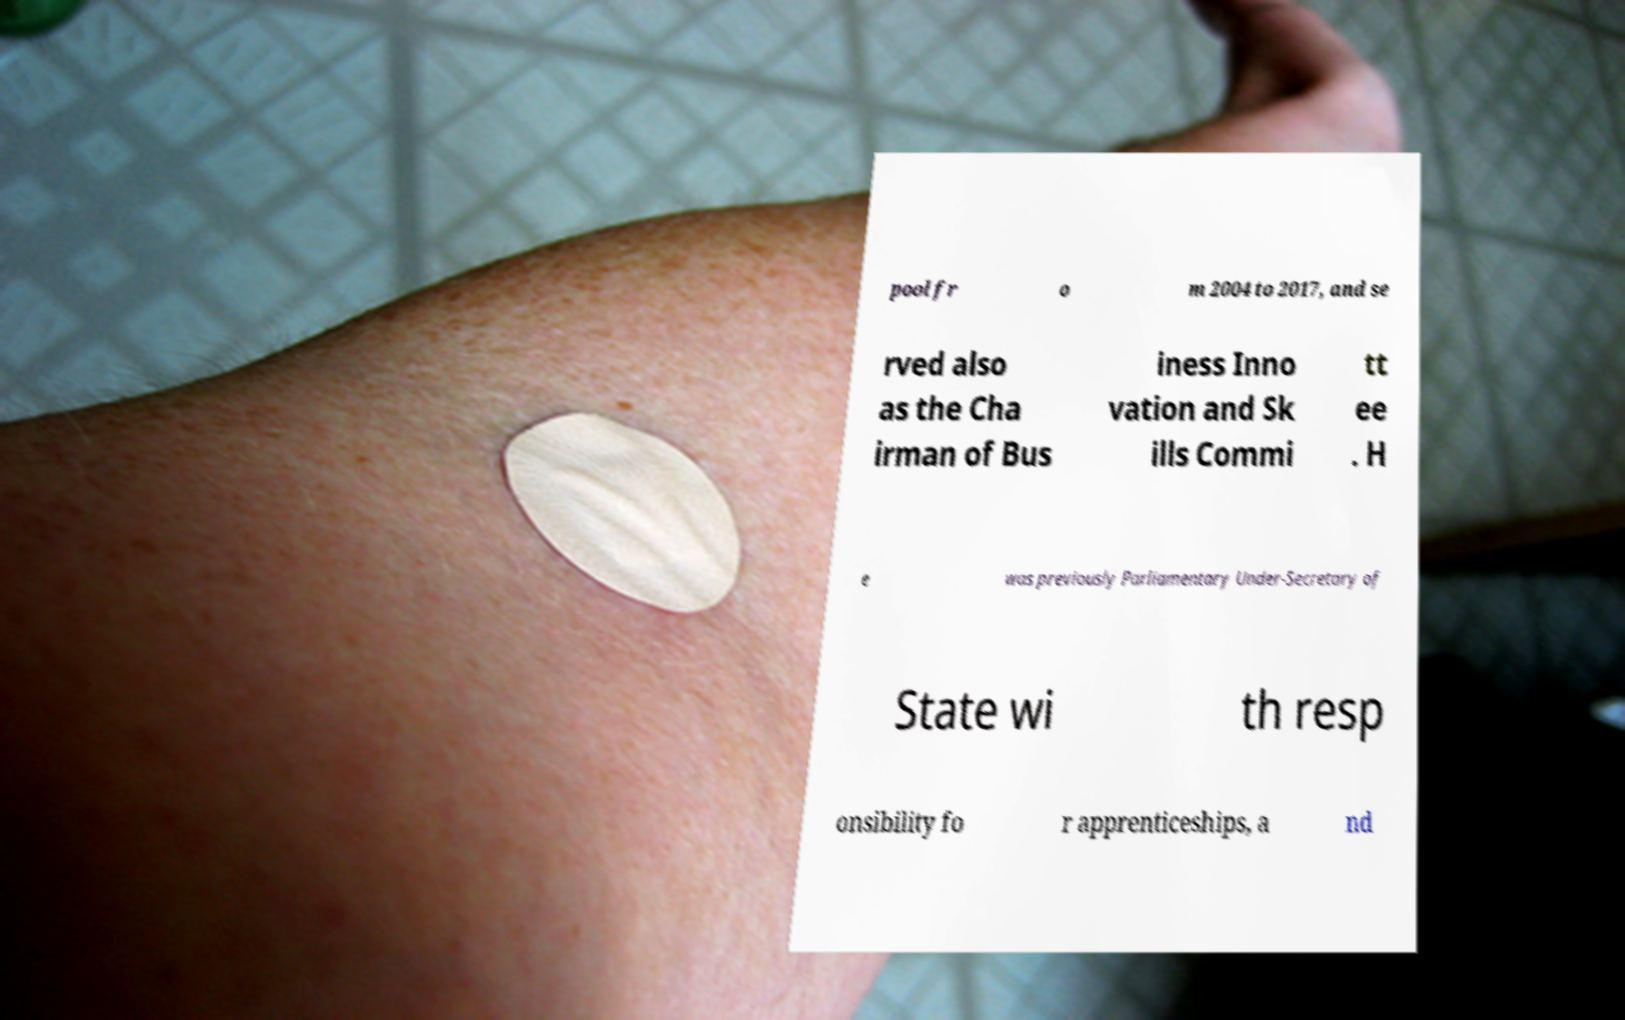Please read and relay the text visible in this image. What does it say? pool fr o m 2004 to 2017, and se rved also as the Cha irman of Bus iness Inno vation and Sk ills Commi tt ee . H e was previously Parliamentary Under-Secretary of State wi th resp onsibility fo r apprenticeships, a nd 